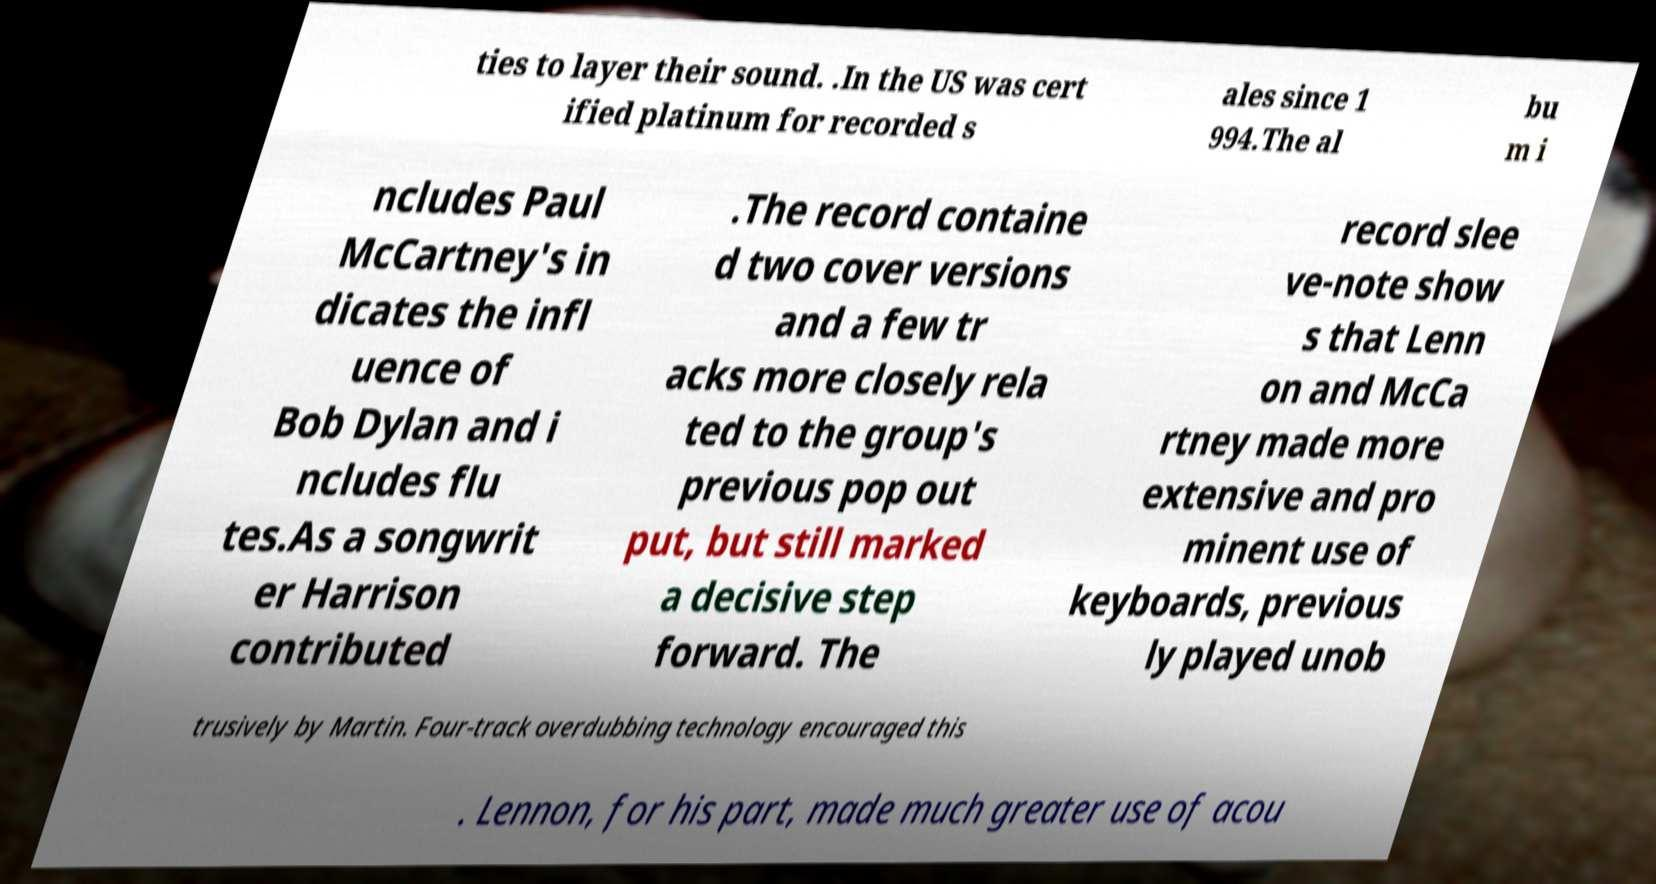I need the written content from this picture converted into text. Can you do that? ties to layer their sound. .In the US was cert ified platinum for recorded s ales since 1 994.The al bu m i ncludes Paul McCartney's in dicates the infl uence of Bob Dylan and i ncludes flu tes.As a songwrit er Harrison contributed .The record containe d two cover versions and a few tr acks more closely rela ted to the group's previous pop out put, but still marked a decisive step forward. The record slee ve-note show s that Lenn on and McCa rtney made more extensive and pro minent use of keyboards, previous ly played unob trusively by Martin. Four-track overdubbing technology encouraged this . Lennon, for his part, made much greater use of acou 